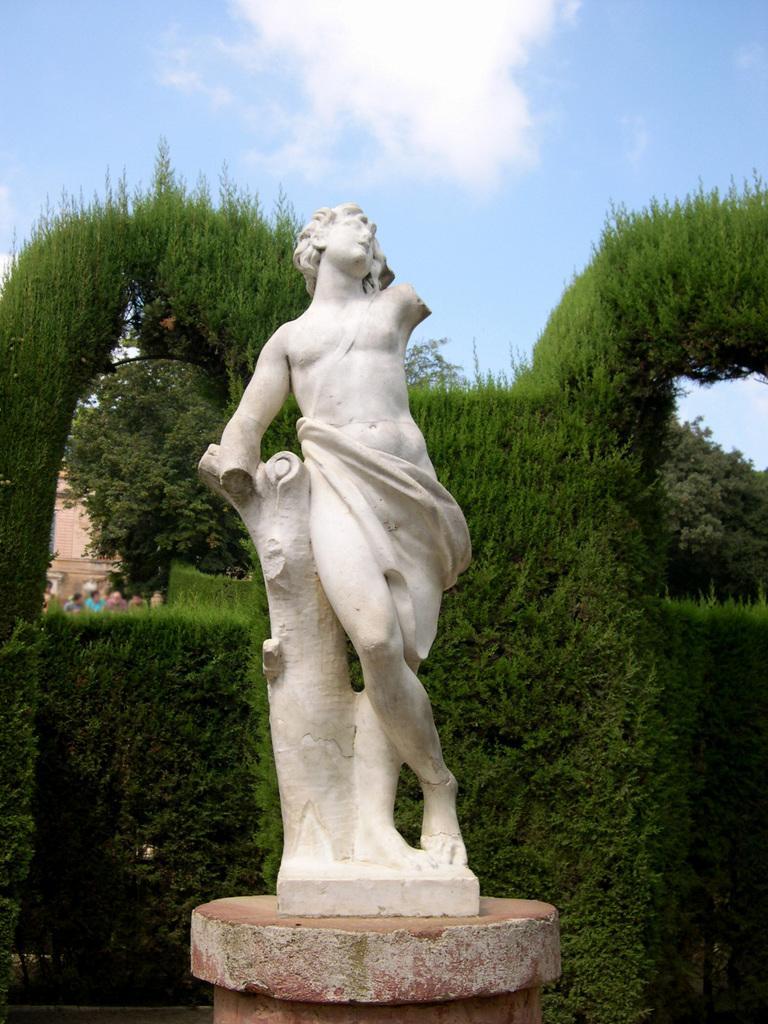Please provide a concise description of this image. In the foreground of the picture I can see a statue. In the background, I can see the structured bushes and trees. I can see a few people on the left side. There are clouds in the sky. 